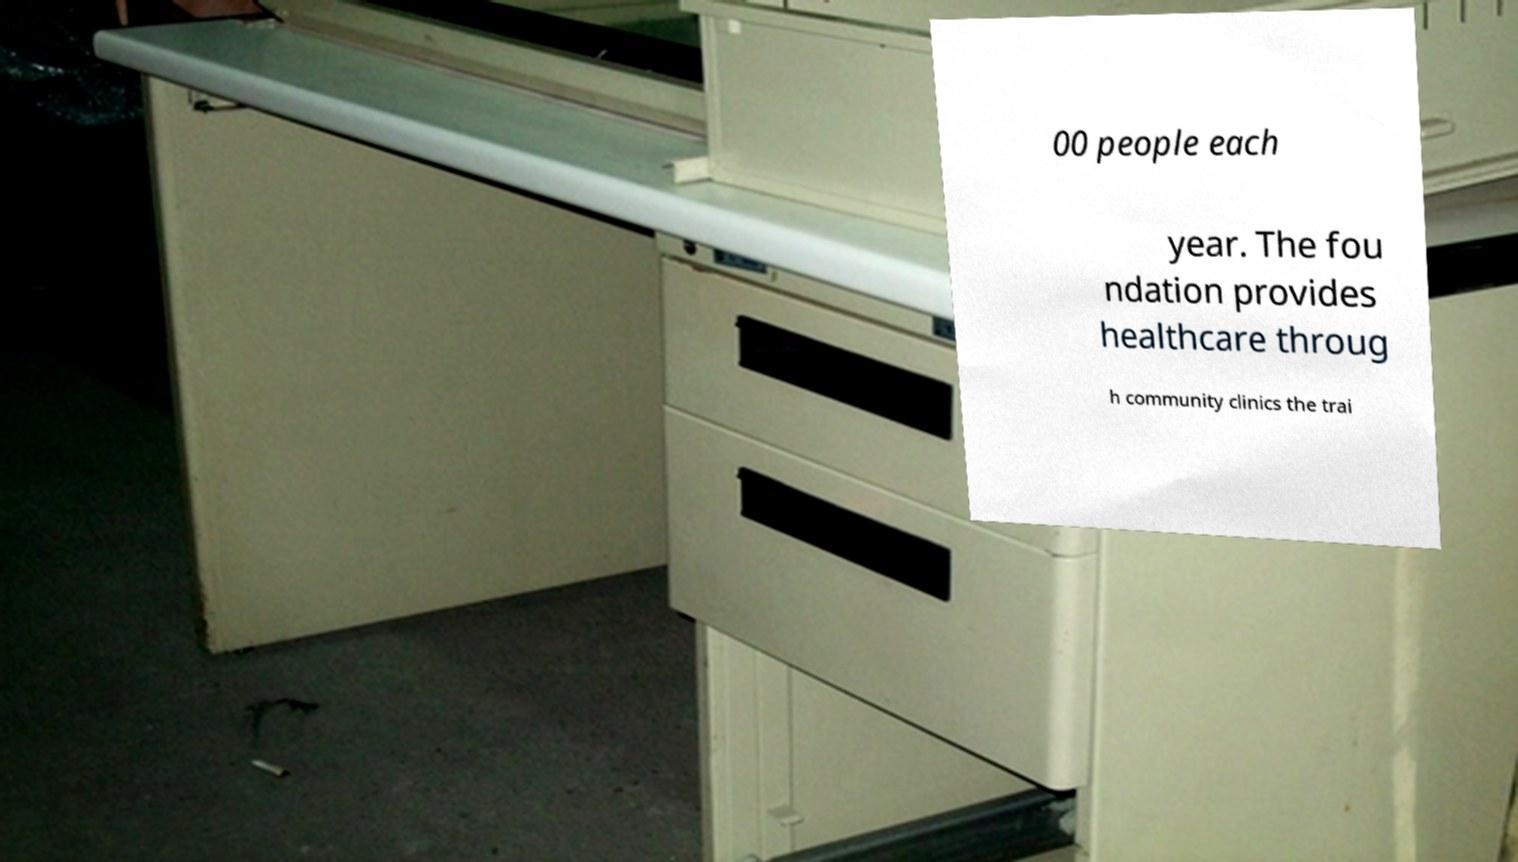I need the written content from this picture converted into text. Can you do that? 00 people each year. The fou ndation provides healthcare throug h community clinics the trai 